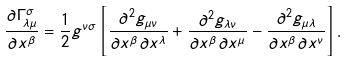<formula> <loc_0><loc_0><loc_500><loc_500>\frac { \partial \Gamma ^ { \sigma } _ { \lambda \mu } } { \partial x ^ { \beta } } = \frac { 1 } { 2 } g ^ { \nu \sigma } \left [ \frac { \partial ^ { 2 } g _ { \mu \nu } } { \partial x ^ { \beta } \partial x ^ { \lambda } } + \frac { \partial ^ { 2 } g _ { \lambda \nu } } { \partial x ^ { \beta } \partial x ^ { \mu } } - \frac { \partial ^ { 2 } g _ { \mu \lambda } } { \partial x ^ { \beta } \partial x ^ { \nu } } \right ] .</formula> 